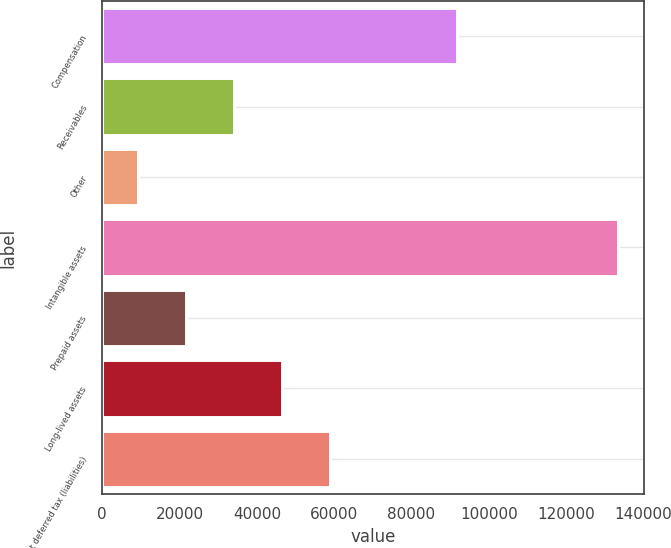Convert chart. <chart><loc_0><loc_0><loc_500><loc_500><bar_chart><fcel>Compensation<fcel>Receivables<fcel>Other<fcel>Intangible assets<fcel>Prepaid assets<fcel>Long-lived assets<fcel>Net deferred tax (liabilities)<nl><fcel>91729<fcel>34068.6<fcel>9242<fcel>133375<fcel>21655.3<fcel>46481.9<fcel>58895.2<nl></chart> 